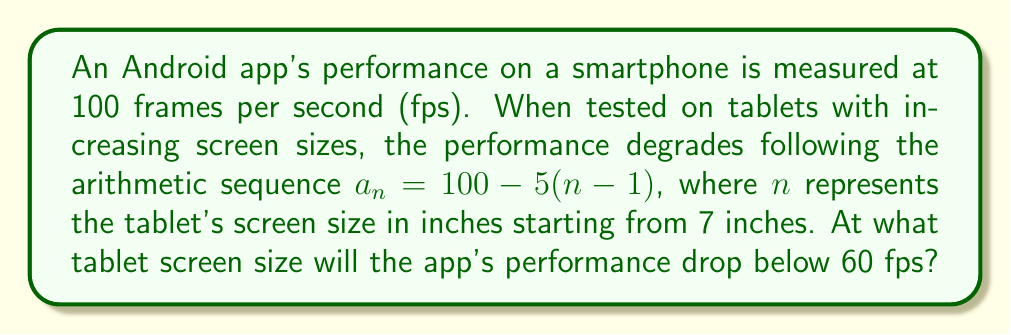Can you answer this question? Let's approach this step-by-step:

1) The given arithmetic sequence is $a_n = 100 - 5(n-1)$, where $a_n$ is the fps and $n$ is the screen size in inches.

2) We need to find $n$ when $a_n < 60$. Let's set up the inequality:

   $100 - 5(n-1) < 60$

3) Simplify the left side:

   $100 - 5n + 5 < 60$
   $105 - 5n < 60$

4) Subtract 105 from both sides:

   $-5n < -45$

5) Divide both sides by -5 (remember to flip the inequality sign):

   $n > 9$

6) Since $n$ represents screen size in inches and must be a whole number, the smallest value of $n$ that satisfies this inequality is 10.

7) To verify:
   For $n = 10$: $a_{10} = 100 - 5(10-1) = 100 - 45 = 55$ fps
   Indeed, 55 fps is below 60 fps.

Therefore, the app's performance will drop below 60 fps when the tablet screen size reaches 10 inches.
Answer: 10 inches 